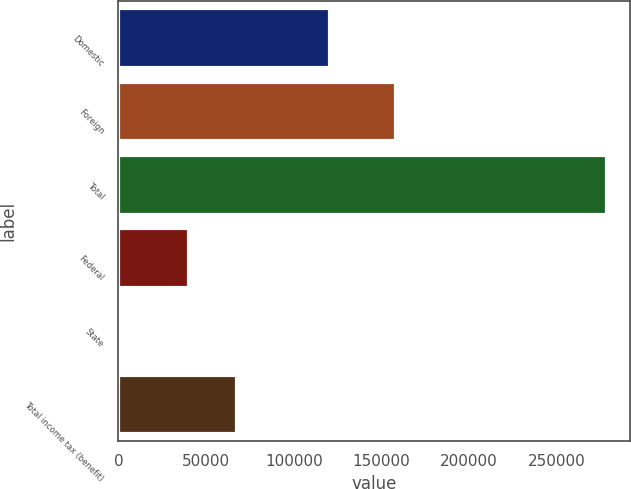Convert chart to OTSL. <chart><loc_0><loc_0><loc_500><loc_500><bar_chart><fcel>Domestic<fcel>Foreign<fcel>Total<fcel>Federal<fcel>State<fcel>Total income tax (benefit)<nl><fcel>120190<fcel>157629<fcel>277819<fcel>39456<fcel>1309<fcel>67107<nl></chart> 